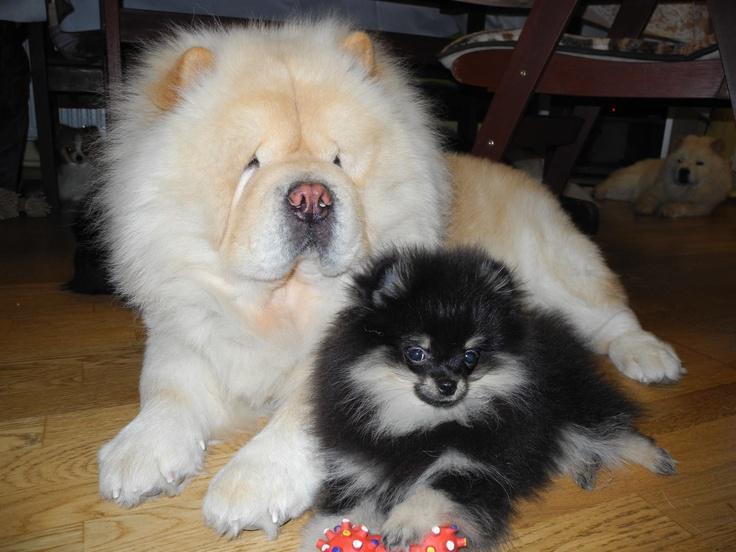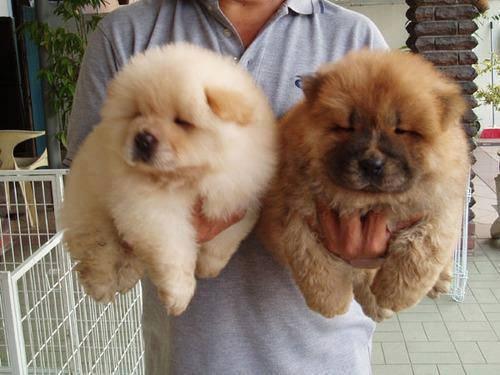The first image is the image on the left, the second image is the image on the right. Examine the images to the left and right. Is the description "Exactly four dogs are shown in groups of two." accurate? Answer yes or no. Yes. The first image is the image on the left, the second image is the image on the right. Examine the images to the left and right. Is the description "THere are exactly two dogs in the image on the left." accurate? Answer yes or no. Yes. 